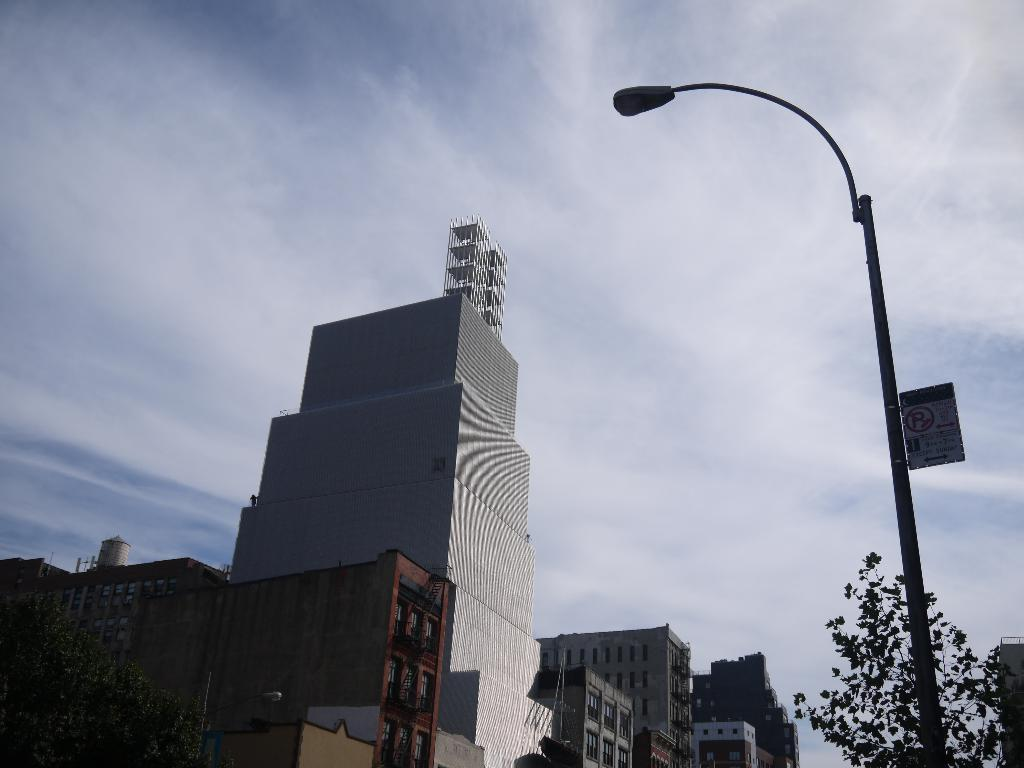What is located at the bottom of the image? There are trees, poles, and buildings at the bottom of the image. Can you describe the sky in the image? There are clouds and sky visible at the top of the image. Is there any snow visible in the image? There is no snow present in the image. What type of wilderness can be seen in the image? There is no wilderness depicted in the image; it features trees, poles, buildings, clouds, and sky. 